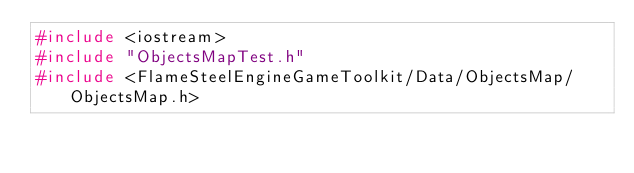<code> <loc_0><loc_0><loc_500><loc_500><_C++_>#include <iostream>
#include "ObjectsMapTest.h"
#include <FlameSteelEngineGameToolkit/Data/ObjectsMap/ObjectsMap.h></code> 